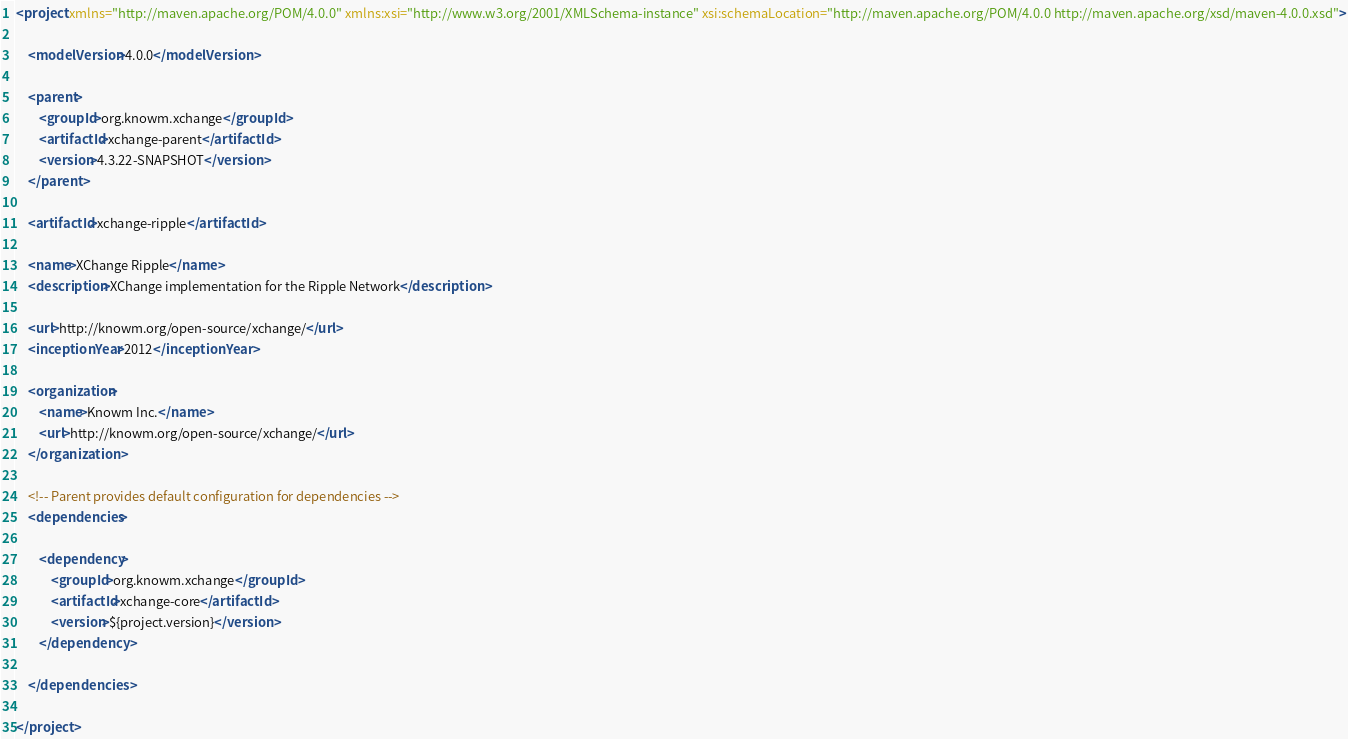Convert code to text. <code><loc_0><loc_0><loc_500><loc_500><_XML_><project xmlns="http://maven.apache.org/POM/4.0.0" xmlns:xsi="http://www.w3.org/2001/XMLSchema-instance" xsi:schemaLocation="http://maven.apache.org/POM/4.0.0 http://maven.apache.org/xsd/maven-4.0.0.xsd">

    <modelVersion>4.0.0</modelVersion>

    <parent>
        <groupId>org.knowm.xchange</groupId>
        <artifactId>xchange-parent</artifactId>
        <version>4.3.22-SNAPSHOT</version>
    </parent>

    <artifactId>xchange-ripple</artifactId>

    <name>XChange Ripple</name>
    <description>XChange implementation for the Ripple Network</description>

    <url>http://knowm.org/open-source/xchange/</url>
    <inceptionYear>2012</inceptionYear>

    <organization>
        <name>Knowm Inc.</name>
        <url>http://knowm.org/open-source/xchange/</url>
    </organization>

    <!-- Parent provides default configuration for dependencies -->
    <dependencies>

        <dependency>
            <groupId>org.knowm.xchange</groupId>
            <artifactId>xchange-core</artifactId>
            <version>${project.version}</version>
        </dependency>

    </dependencies>

</project>
</code> 